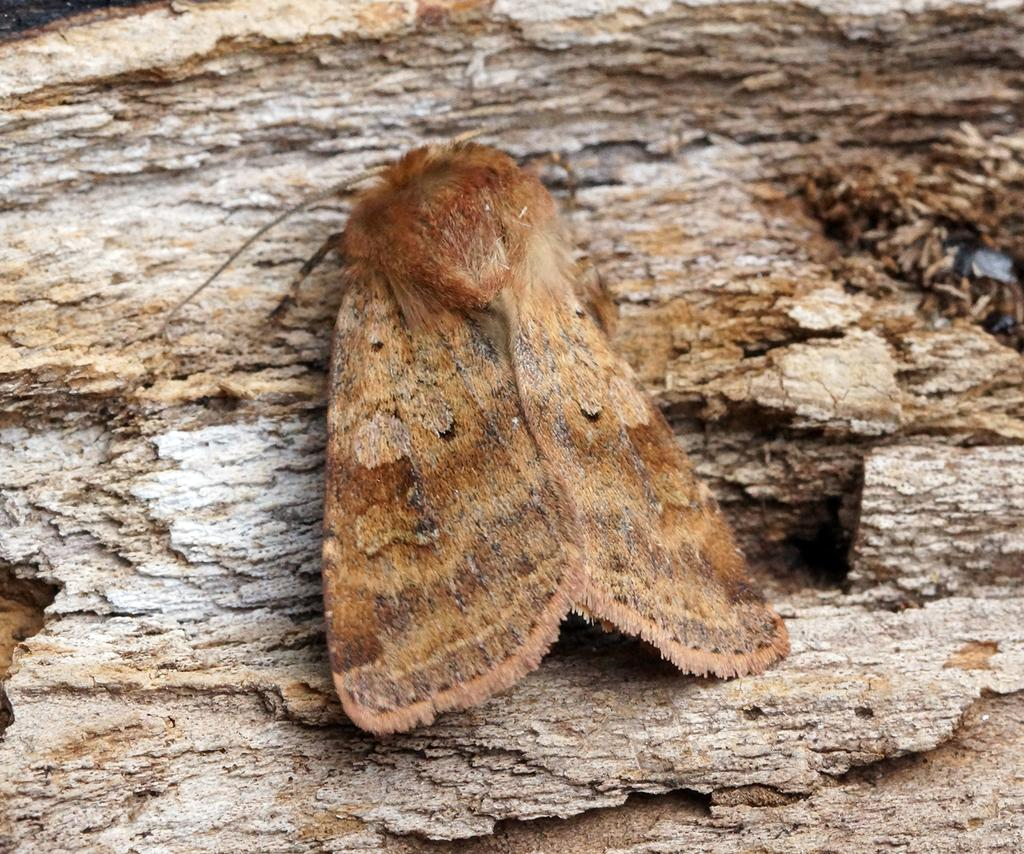What type of creature can be seen in the image? There is an insect in the image. What is the insect resting on in the image? The insect is on a wooden surface. What type of vein is visible in the image? There is no vein visible in the image; it features an insect on a wooden surface. What arithmetic problem is the insect trying to solve in the image? There is no arithmetic problem present in the image; it features an insect on a wooden surface. 